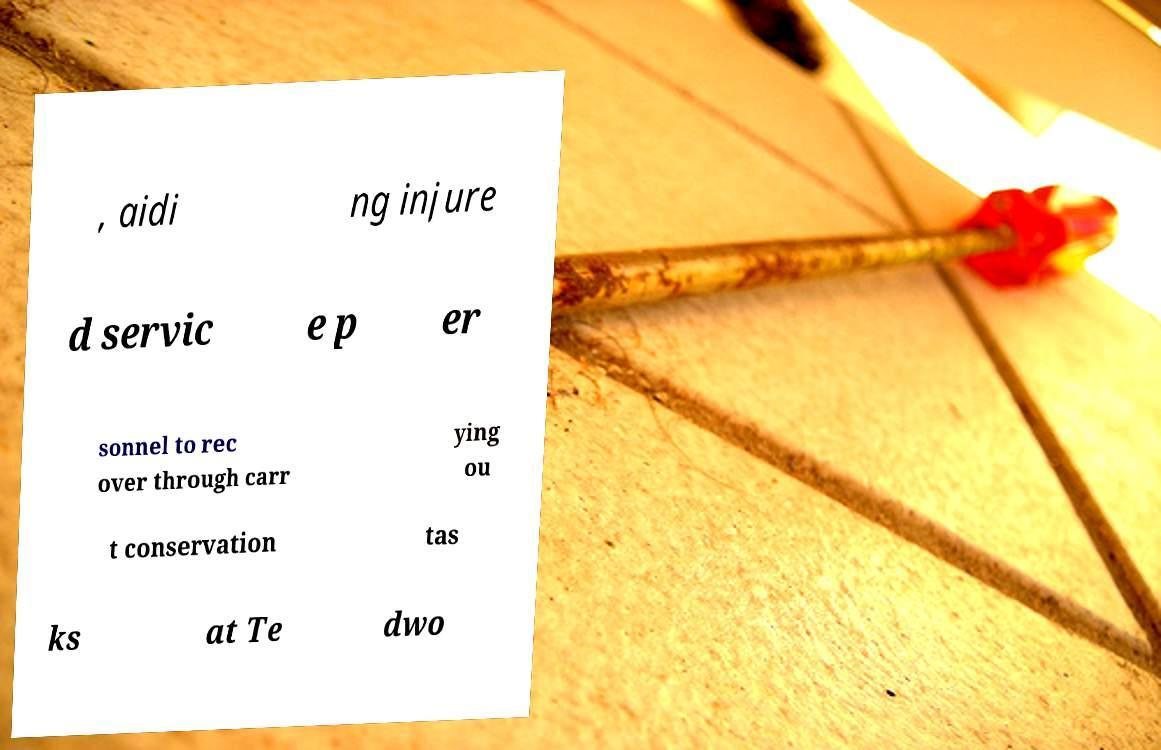Please identify and transcribe the text found in this image. , aidi ng injure d servic e p er sonnel to rec over through carr ying ou t conservation tas ks at Te dwo 